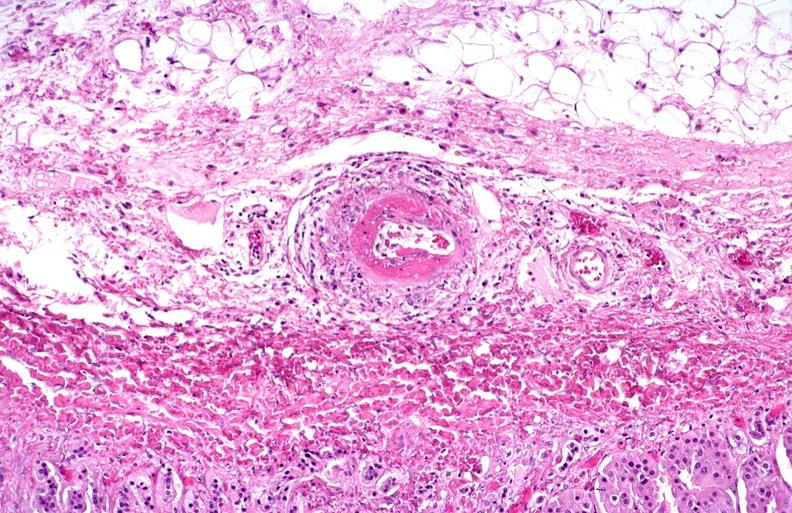s vasculature present?
Answer the question using a single word or phrase. Yes 